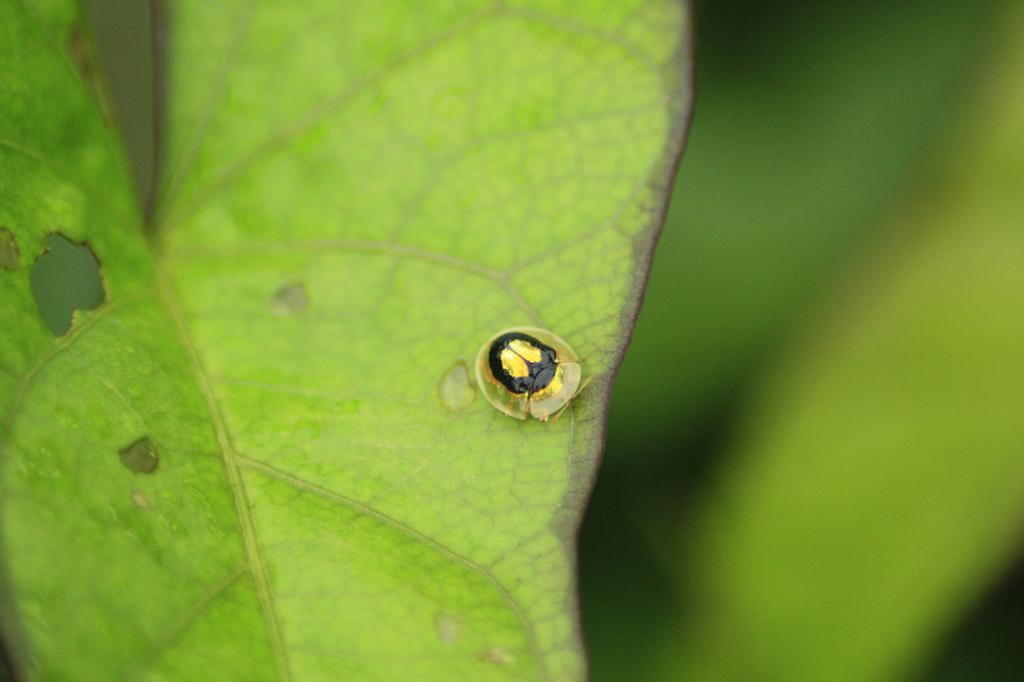What is the color of the leaf in the image? The leaf in the image is green. Can you describe any other objects or creatures on the leaf? Yes, there is a black insect on the leaf. What type of club is visible in the image? There is no club present in the image; it features a green leaf with a black insect on it. 